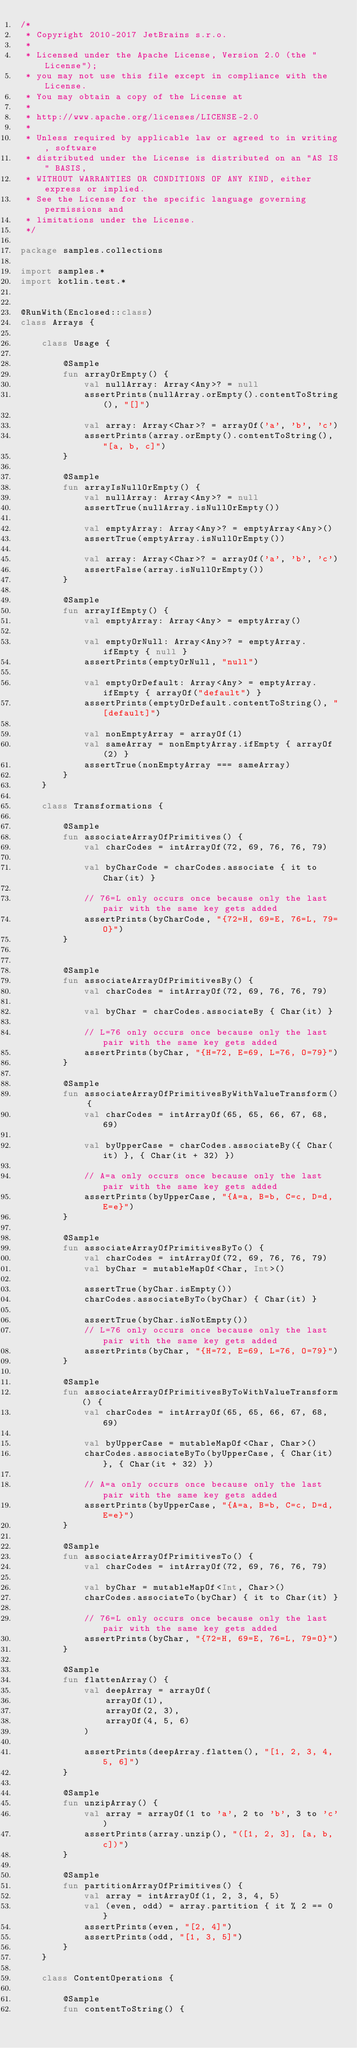Convert code to text. <code><loc_0><loc_0><loc_500><loc_500><_Kotlin_>/*
 * Copyright 2010-2017 JetBrains s.r.o.
 *
 * Licensed under the Apache License, Version 2.0 (the "License");
 * you may not use this file except in compliance with the License.
 * You may obtain a copy of the License at
 *
 * http://www.apache.org/licenses/LICENSE-2.0
 *
 * Unless required by applicable law or agreed to in writing, software
 * distributed under the License is distributed on an "AS IS" BASIS,
 * WITHOUT WARRANTIES OR CONDITIONS OF ANY KIND, either express or implied.
 * See the License for the specific language governing permissions and
 * limitations under the License.
 */

package samples.collections

import samples.*
import kotlin.test.*


@RunWith(Enclosed::class)
class Arrays {

    class Usage {

        @Sample
        fun arrayOrEmpty() {
            val nullArray: Array<Any>? = null
            assertPrints(nullArray.orEmpty().contentToString(), "[]")

            val array: Array<Char>? = arrayOf('a', 'b', 'c')
            assertPrints(array.orEmpty().contentToString(), "[a, b, c]")
        }

        @Sample
        fun arrayIsNullOrEmpty() {
            val nullArray: Array<Any>? = null
            assertTrue(nullArray.isNullOrEmpty())

            val emptyArray: Array<Any>? = emptyArray<Any>()
            assertTrue(emptyArray.isNullOrEmpty())

            val array: Array<Char>? = arrayOf('a', 'b', 'c')
            assertFalse(array.isNullOrEmpty())
        }

        @Sample
        fun arrayIfEmpty() {
            val emptyArray: Array<Any> = emptyArray()

            val emptyOrNull: Array<Any>? = emptyArray.ifEmpty { null }
            assertPrints(emptyOrNull, "null")

            val emptyOrDefault: Array<Any> = emptyArray.ifEmpty { arrayOf("default") }
            assertPrints(emptyOrDefault.contentToString(), "[default]")

            val nonEmptyArray = arrayOf(1)
            val sameArray = nonEmptyArray.ifEmpty { arrayOf(2) }
            assertTrue(nonEmptyArray === sameArray)
        }
    }

    class Transformations {

        @Sample
        fun associateArrayOfPrimitives() {
            val charCodes = intArrayOf(72, 69, 76, 76, 79)

            val byCharCode = charCodes.associate { it to Char(it) }

            // 76=L only occurs once because only the last pair with the same key gets added
            assertPrints(byCharCode, "{72=H, 69=E, 76=L, 79=O}")
        }


        @Sample
        fun associateArrayOfPrimitivesBy() {
            val charCodes = intArrayOf(72, 69, 76, 76, 79)

            val byChar = charCodes.associateBy { Char(it) }

            // L=76 only occurs once because only the last pair with the same key gets added
            assertPrints(byChar, "{H=72, E=69, L=76, O=79}")
        }

        @Sample
        fun associateArrayOfPrimitivesByWithValueTransform() {
            val charCodes = intArrayOf(65, 65, 66, 67, 68, 69)

            val byUpperCase = charCodes.associateBy({ Char(it) }, { Char(it + 32) })

            // A=a only occurs once because only the last pair with the same key gets added
            assertPrints(byUpperCase, "{A=a, B=b, C=c, D=d, E=e}")
        }

        @Sample
        fun associateArrayOfPrimitivesByTo() {
            val charCodes = intArrayOf(72, 69, 76, 76, 79)
            val byChar = mutableMapOf<Char, Int>()

            assertTrue(byChar.isEmpty())
            charCodes.associateByTo(byChar) { Char(it) }

            assertTrue(byChar.isNotEmpty())
            // L=76 only occurs once because only the last pair with the same key gets added
            assertPrints(byChar, "{H=72, E=69, L=76, O=79}")
        }

        @Sample
        fun associateArrayOfPrimitivesByToWithValueTransform() {
            val charCodes = intArrayOf(65, 65, 66, 67, 68, 69)

            val byUpperCase = mutableMapOf<Char, Char>()
            charCodes.associateByTo(byUpperCase, { Char(it) }, { Char(it + 32) })

            // A=a only occurs once because only the last pair with the same key gets added
            assertPrints(byUpperCase, "{A=a, B=b, C=c, D=d, E=e}")
        }

        @Sample
        fun associateArrayOfPrimitivesTo() {
            val charCodes = intArrayOf(72, 69, 76, 76, 79)

            val byChar = mutableMapOf<Int, Char>()
            charCodes.associateTo(byChar) { it to Char(it) }

            // 76=L only occurs once because only the last pair with the same key gets added
            assertPrints(byChar, "{72=H, 69=E, 76=L, 79=O}")
        }

        @Sample
        fun flattenArray() {
            val deepArray = arrayOf(
                arrayOf(1),
                arrayOf(2, 3),
                arrayOf(4, 5, 6)
            )

            assertPrints(deepArray.flatten(), "[1, 2, 3, 4, 5, 6]")
        }

        @Sample
        fun unzipArray() {
            val array = arrayOf(1 to 'a', 2 to 'b', 3 to 'c')
            assertPrints(array.unzip(), "([1, 2, 3], [a, b, c])")
        }

        @Sample
        fun partitionArrayOfPrimitives() {
            val array = intArrayOf(1, 2, 3, 4, 5)
            val (even, odd) = array.partition { it % 2 == 0 }
            assertPrints(even, "[2, 4]")
            assertPrints(odd, "[1, 3, 5]")
        }
    }

    class ContentOperations {

        @Sample
        fun contentToString() {</code> 